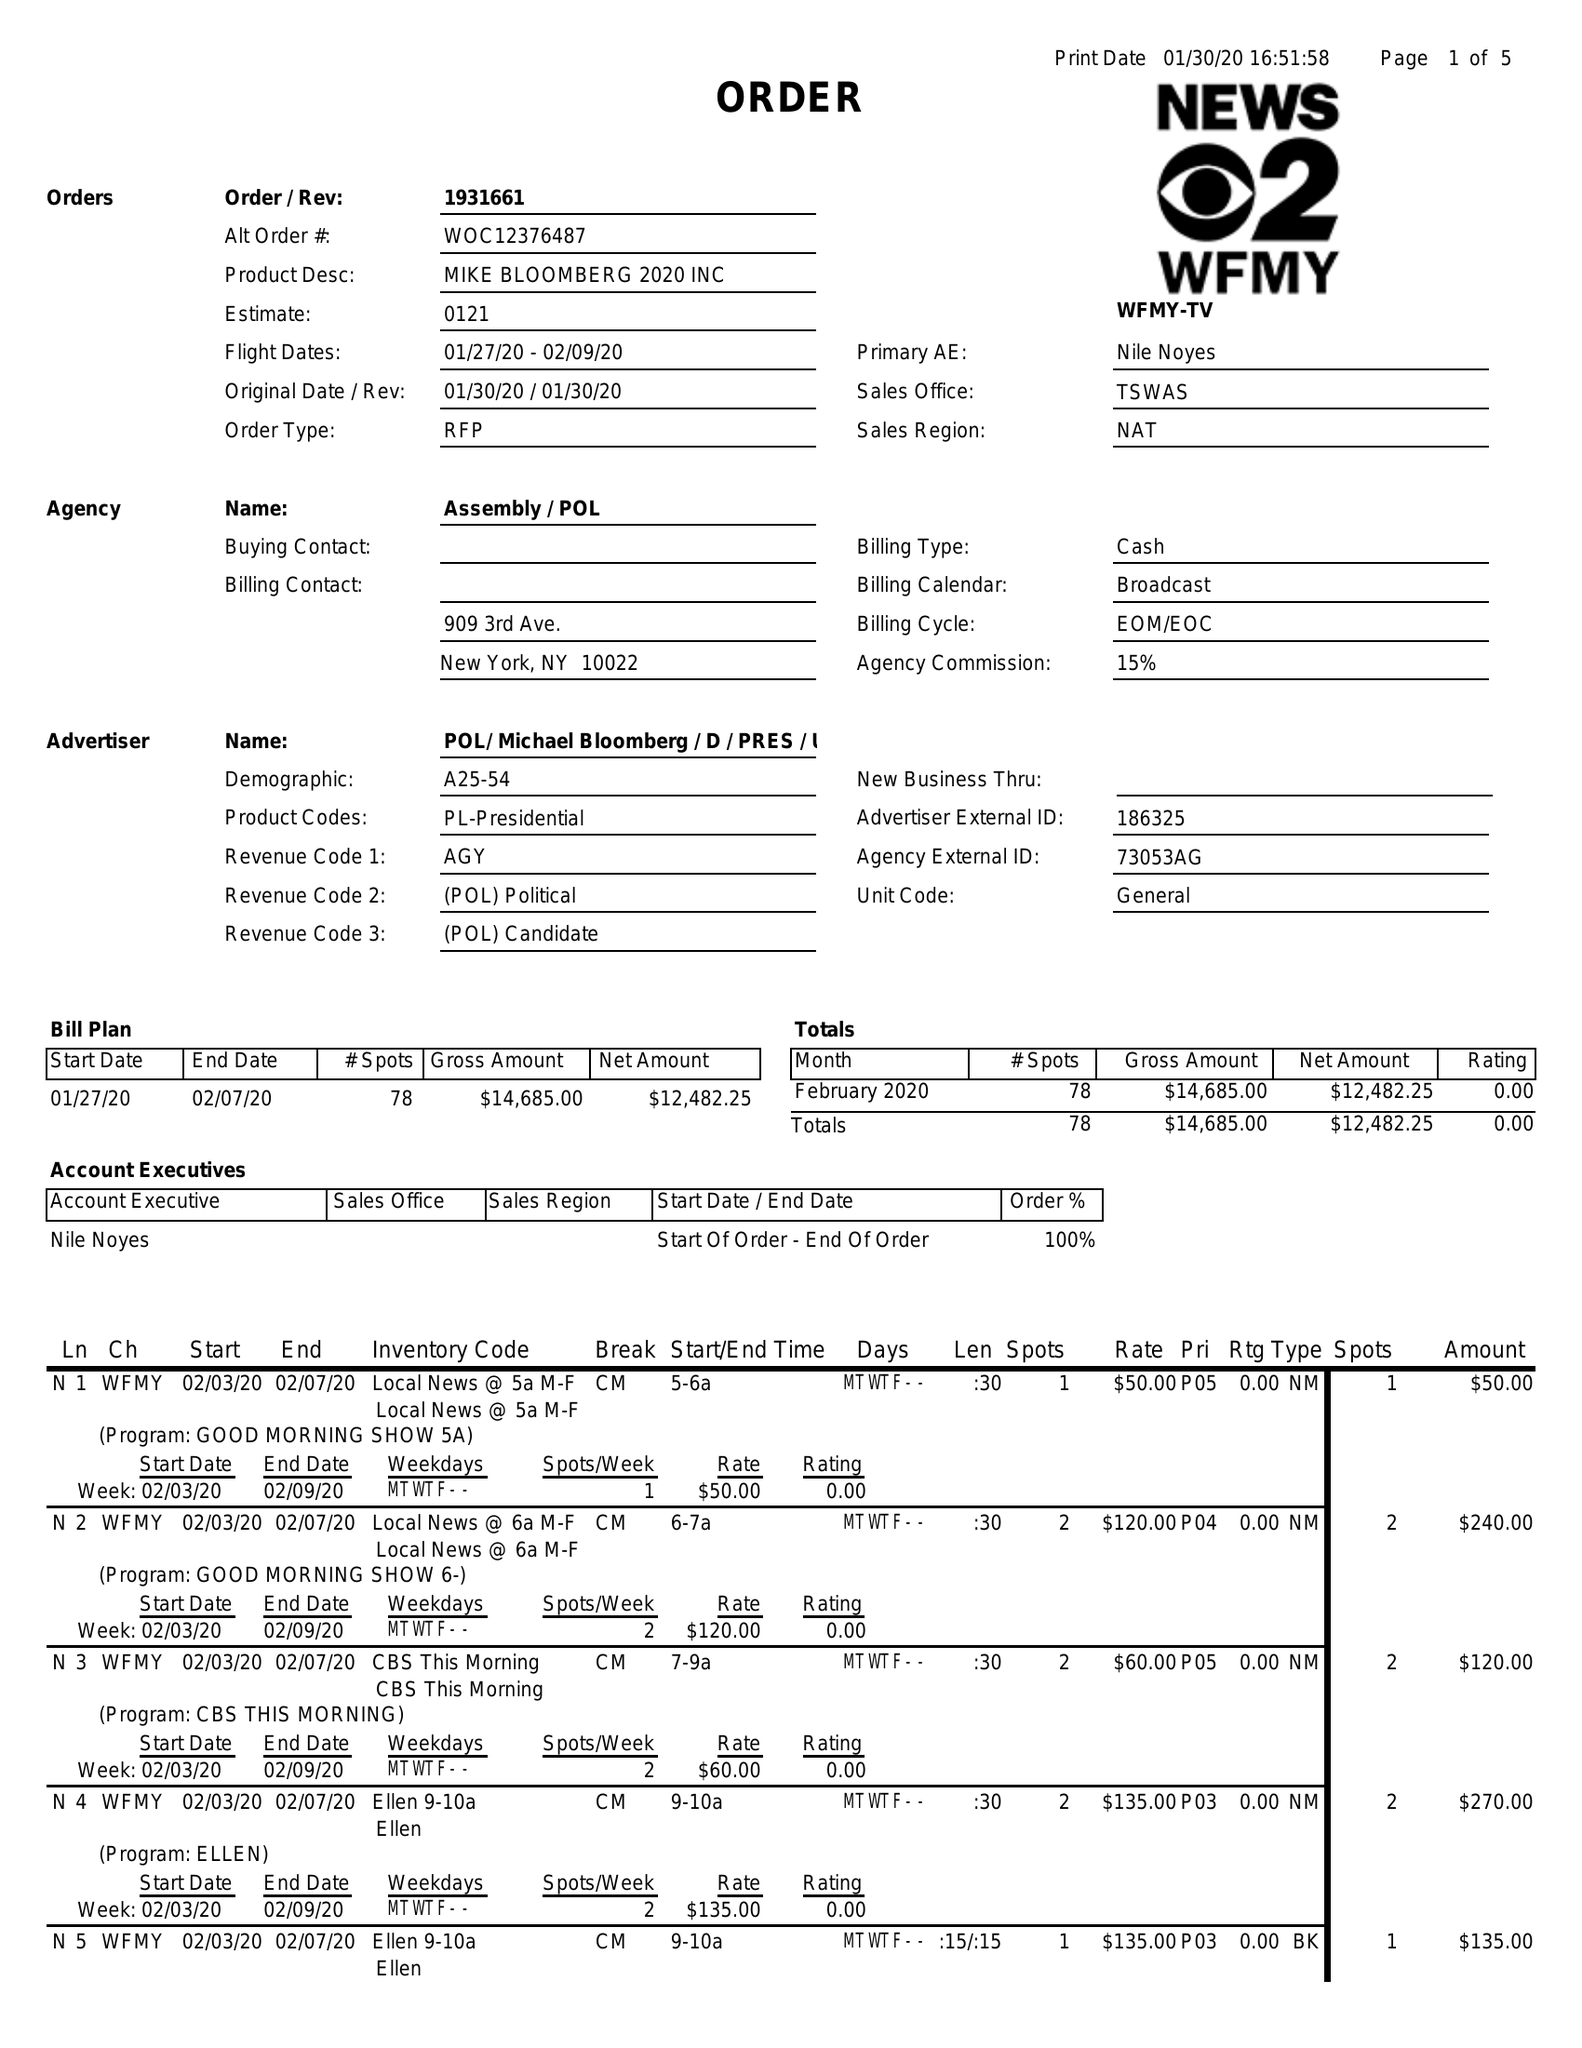What is the value for the flight_to?
Answer the question using a single word or phrase. 02/09/20 